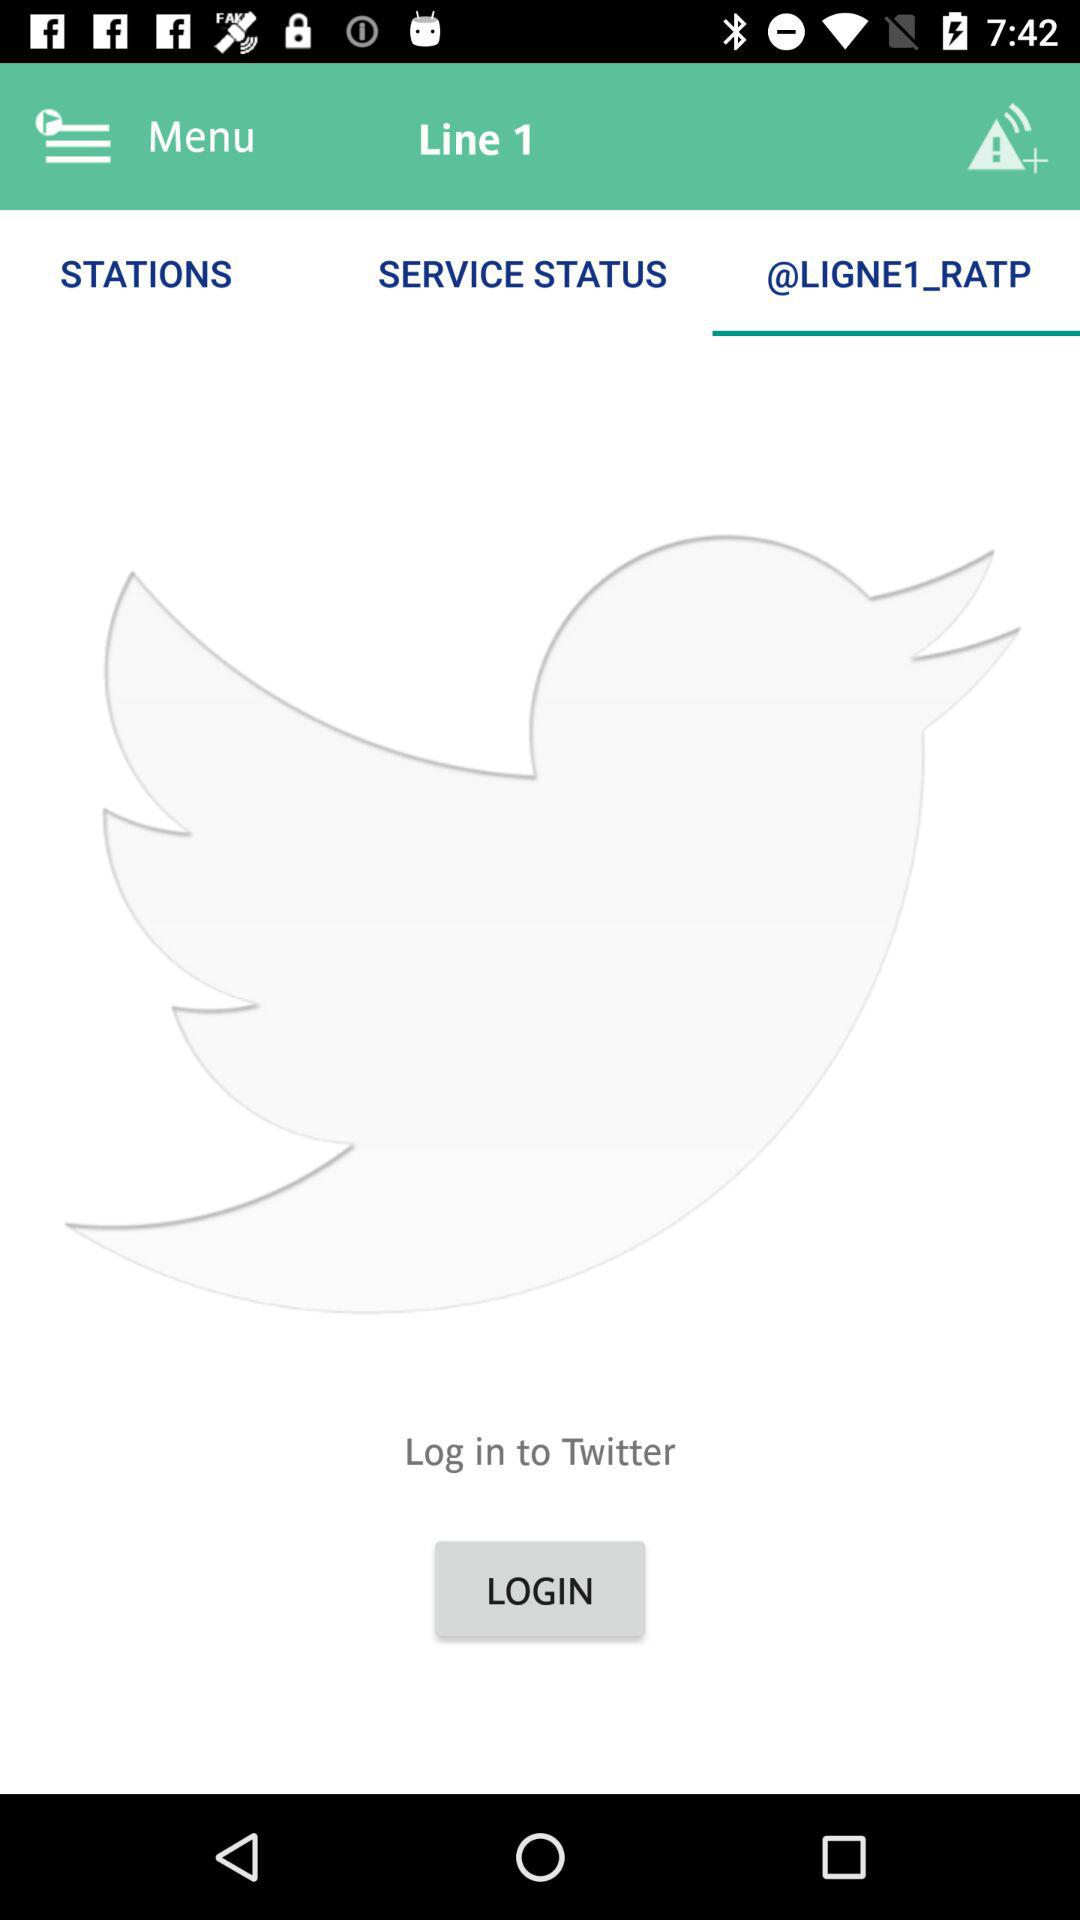Which tab has been selected? The selected tab is "@LIGNE1_RATP". 